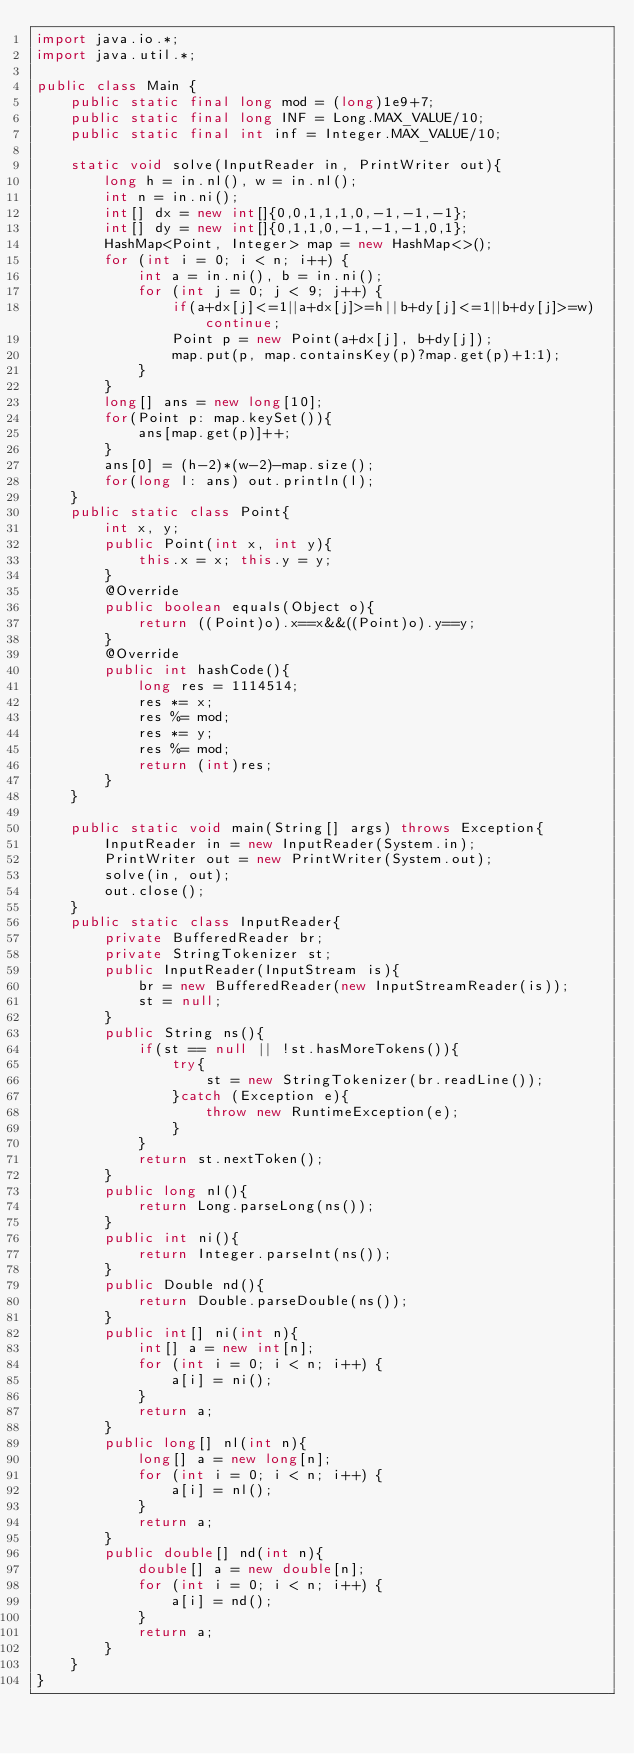Convert code to text. <code><loc_0><loc_0><loc_500><loc_500><_Java_>import java.io.*;
import java.util.*;

public class Main {
    public static final long mod = (long)1e9+7;
    public static final long INF = Long.MAX_VALUE/10;
    public static final int inf = Integer.MAX_VALUE/10;

    static void solve(InputReader in, PrintWriter out){
        long h = in.nl(), w = in.nl();
        int n = in.ni();
        int[] dx = new int[]{0,0,1,1,1,0,-1,-1,-1};
        int[] dy = new int[]{0,1,1,0,-1,-1,-1,0,1};
        HashMap<Point, Integer> map = new HashMap<>();
        for (int i = 0; i < n; i++) {
            int a = in.ni(), b = in.ni();
            for (int j = 0; j < 9; j++) {
                if(a+dx[j]<=1||a+dx[j]>=h||b+dy[j]<=1||b+dy[j]>=w) continue;
                Point p = new Point(a+dx[j], b+dy[j]);
                map.put(p, map.containsKey(p)?map.get(p)+1:1);
            }
        }
        long[] ans = new long[10];
        for(Point p: map.keySet()){
            ans[map.get(p)]++;
        }
        ans[0] = (h-2)*(w-2)-map.size();
        for(long l: ans) out.println(l);
    }
    public static class Point{
        int x, y;
        public Point(int x, int y){
            this.x = x; this.y = y;
        }
        @Override
        public boolean equals(Object o){
            return ((Point)o).x==x&&((Point)o).y==y;
        }
        @Override
        public int hashCode(){
            long res = 1114514;
            res *= x;
            res %= mod;
            res *= y;
            res %= mod;
            return (int)res;
        }
    }

    public static void main(String[] args) throws Exception{
        InputReader in = new InputReader(System.in);
        PrintWriter out = new PrintWriter(System.out);
        solve(in, out);
        out.close();
    }
    public static class InputReader{
        private BufferedReader br;
        private StringTokenizer st;
        public InputReader(InputStream is){
            br = new BufferedReader(new InputStreamReader(is));
            st = null;
        }
        public String ns(){
            if(st == null || !st.hasMoreTokens()){
                try{
                    st = new StringTokenizer(br.readLine());
                }catch (Exception e){
                    throw new RuntimeException(e);
                }
            }
            return st.nextToken();
        }
        public long nl(){
            return Long.parseLong(ns());
        }
        public int ni(){
            return Integer.parseInt(ns());
        }
        public Double nd(){
            return Double.parseDouble(ns());
        }
        public int[] ni(int n){
            int[] a = new int[n];
            for (int i = 0; i < n; i++) {
                a[i] = ni();
            }
            return a;
        }
        public long[] nl(int n){
            long[] a = new long[n];
            for (int i = 0; i < n; i++) {
                a[i] = nl();
            }
            return a;
        }
        public double[] nd(int n){
            double[] a = new double[n];
            for (int i = 0; i < n; i++) {
                a[i] = nd();
            }
            return a;
        }
    }
}</code> 